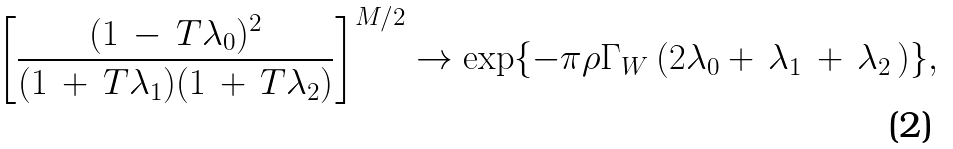Convert formula to latex. <formula><loc_0><loc_0><loc_500><loc_500>\left [ \frac { ( 1 \, - \, T \lambda _ { 0 } ) ^ { 2 } } { ( 1 \, + \, T \lambda _ { 1 } ) ( 1 \, + \, T \lambda _ { 2 } ) } \right ] ^ { M / 2 } \rightarrow \exp \{ - \pi \rho \Gamma _ { W } \, ( 2 \lambda _ { 0 } + \, \lambda _ { 1 } \, + \, \lambda _ { 2 } \, ) \} ,</formula> 